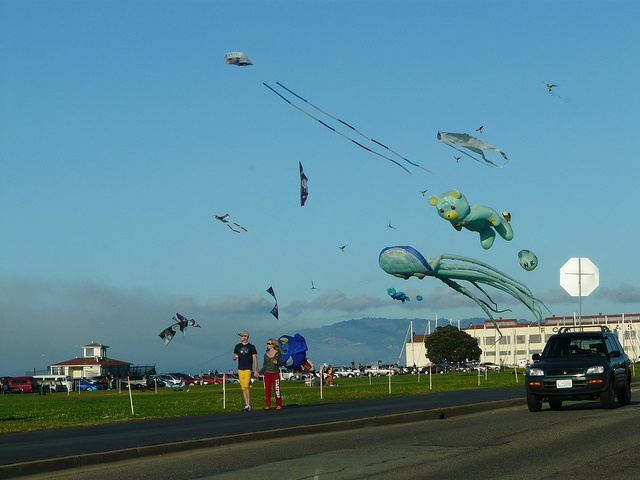Describe the objects in this image and their specific colors. I can see car in gray, black, blue, and beige tones, kite in gray, teal, and darkgray tones, kite in gray, lightblue, teal, and darkgreen tones, kite in gray, teal, and black tones, and car in gray, black, darkgray, and darkgreen tones in this image. 